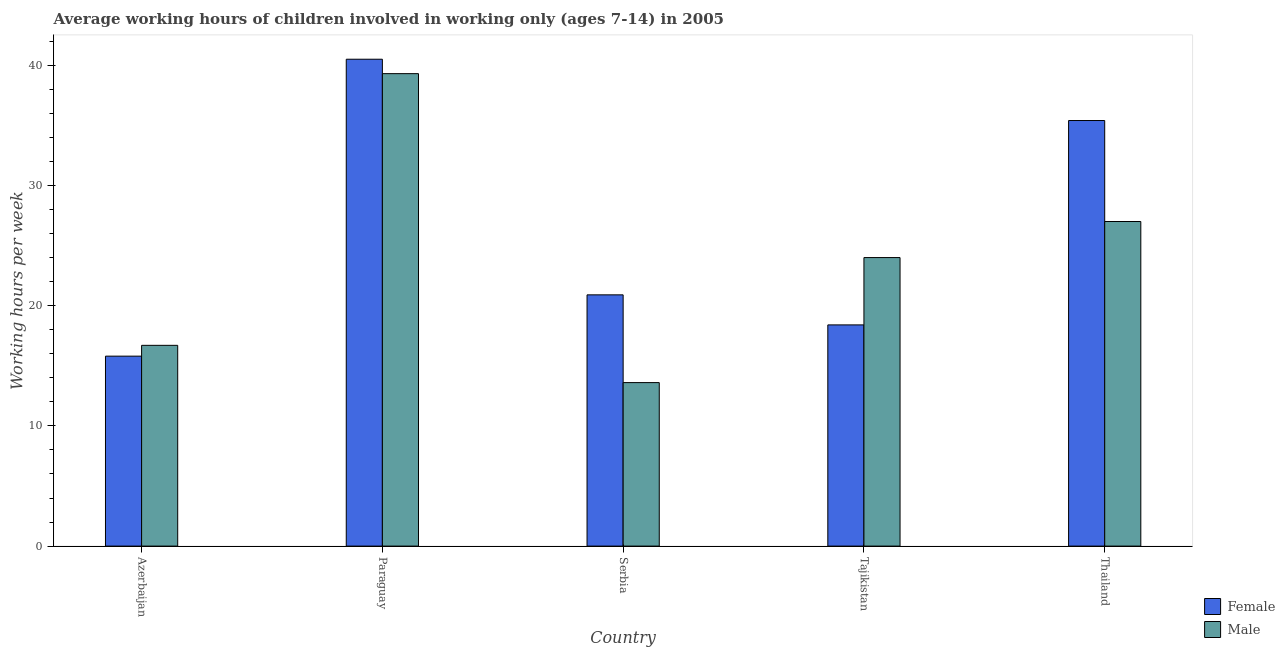How many different coloured bars are there?
Provide a succinct answer. 2. How many groups of bars are there?
Offer a terse response. 5. Are the number of bars per tick equal to the number of legend labels?
Ensure brevity in your answer.  Yes. How many bars are there on the 3rd tick from the left?
Make the answer very short. 2. What is the label of the 5th group of bars from the left?
Your response must be concise. Thailand. Across all countries, what is the maximum average working hour of female children?
Provide a succinct answer. 40.5. In which country was the average working hour of male children maximum?
Offer a very short reply. Paraguay. In which country was the average working hour of male children minimum?
Provide a short and direct response. Serbia. What is the total average working hour of male children in the graph?
Give a very brief answer. 120.6. What is the difference between the average working hour of male children in Paraguay and that in Thailand?
Your response must be concise. 12.3. What is the difference between the average working hour of male children in Tajikistan and the average working hour of female children in Serbia?
Give a very brief answer. 3.1. What is the average average working hour of female children per country?
Provide a succinct answer. 26.2. What is the difference between the average working hour of male children and average working hour of female children in Azerbaijan?
Make the answer very short. 0.9. In how many countries, is the average working hour of female children greater than 36 hours?
Keep it short and to the point. 1. What is the ratio of the average working hour of male children in Paraguay to that in Serbia?
Provide a succinct answer. 2.89. Is the difference between the average working hour of male children in Paraguay and Thailand greater than the difference between the average working hour of female children in Paraguay and Thailand?
Your answer should be compact. Yes. What is the difference between the highest and the second highest average working hour of female children?
Your answer should be compact. 5.1. What is the difference between the highest and the lowest average working hour of male children?
Give a very brief answer. 25.7. Is the sum of the average working hour of female children in Serbia and Tajikistan greater than the maximum average working hour of male children across all countries?
Make the answer very short. No. What does the 2nd bar from the left in Tajikistan represents?
Give a very brief answer. Male. What does the 2nd bar from the right in Azerbaijan represents?
Your answer should be very brief. Female. How many bars are there?
Provide a succinct answer. 10. How many countries are there in the graph?
Provide a short and direct response. 5. Does the graph contain any zero values?
Ensure brevity in your answer.  No. How many legend labels are there?
Provide a short and direct response. 2. How are the legend labels stacked?
Offer a terse response. Vertical. What is the title of the graph?
Your answer should be very brief. Average working hours of children involved in working only (ages 7-14) in 2005. What is the label or title of the X-axis?
Keep it short and to the point. Country. What is the label or title of the Y-axis?
Offer a terse response. Working hours per week. What is the Working hours per week of Male in Azerbaijan?
Your answer should be very brief. 16.7. What is the Working hours per week in Female in Paraguay?
Make the answer very short. 40.5. What is the Working hours per week of Male in Paraguay?
Provide a short and direct response. 39.3. What is the Working hours per week of Female in Serbia?
Keep it short and to the point. 20.9. What is the Working hours per week in Male in Serbia?
Keep it short and to the point. 13.6. What is the Working hours per week in Male in Tajikistan?
Keep it short and to the point. 24. What is the Working hours per week in Female in Thailand?
Offer a very short reply. 35.4. Across all countries, what is the maximum Working hours per week in Female?
Ensure brevity in your answer.  40.5. Across all countries, what is the maximum Working hours per week of Male?
Make the answer very short. 39.3. Across all countries, what is the minimum Working hours per week of Female?
Provide a short and direct response. 15.8. What is the total Working hours per week of Female in the graph?
Provide a short and direct response. 131. What is the total Working hours per week of Male in the graph?
Offer a terse response. 120.6. What is the difference between the Working hours per week of Female in Azerbaijan and that in Paraguay?
Your answer should be compact. -24.7. What is the difference between the Working hours per week in Male in Azerbaijan and that in Paraguay?
Your answer should be very brief. -22.6. What is the difference between the Working hours per week in Male in Azerbaijan and that in Serbia?
Provide a succinct answer. 3.1. What is the difference between the Working hours per week in Female in Azerbaijan and that in Tajikistan?
Provide a succinct answer. -2.6. What is the difference between the Working hours per week in Male in Azerbaijan and that in Tajikistan?
Offer a terse response. -7.3. What is the difference between the Working hours per week in Female in Azerbaijan and that in Thailand?
Your answer should be compact. -19.6. What is the difference between the Working hours per week in Female in Paraguay and that in Serbia?
Your response must be concise. 19.6. What is the difference between the Working hours per week of Male in Paraguay and that in Serbia?
Offer a terse response. 25.7. What is the difference between the Working hours per week in Female in Paraguay and that in Tajikistan?
Provide a short and direct response. 22.1. What is the difference between the Working hours per week in Female in Paraguay and that in Thailand?
Your answer should be very brief. 5.1. What is the difference between the Working hours per week of Male in Paraguay and that in Thailand?
Keep it short and to the point. 12.3. What is the difference between the Working hours per week in Female in Serbia and that in Thailand?
Make the answer very short. -14.5. What is the difference between the Working hours per week in Male in Serbia and that in Thailand?
Give a very brief answer. -13.4. What is the difference between the Working hours per week of Female in Tajikistan and that in Thailand?
Provide a short and direct response. -17. What is the difference between the Working hours per week in Female in Azerbaijan and the Working hours per week in Male in Paraguay?
Your answer should be compact. -23.5. What is the difference between the Working hours per week in Female in Azerbaijan and the Working hours per week in Male in Tajikistan?
Provide a succinct answer. -8.2. What is the difference between the Working hours per week in Female in Azerbaijan and the Working hours per week in Male in Thailand?
Your answer should be compact. -11.2. What is the difference between the Working hours per week of Female in Paraguay and the Working hours per week of Male in Serbia?
Offer a terse response. 26.9. What is the difference between the Working hours per week in Female in Paraguay and the Working hours per week in Male in Tajikistan?
Your answer should be very brief. 16.5. What is the difference between the Working hours per week of Female in Paraguay and the Working hours per week of Male in Thailand?
Give a very brief answer. 13.5. What is the difference between the Working hours per week of Female in Serbia and the Working hours per week of Male in Tajikistan?
Offer a very short reply. -3.1. What is the difference between the Working hours per week in Female in Tajikistan and the Working hours per week in Male in Thailand?
Ensure brevity in your answer.  -8.6. What is the average Working hours per week in Female per country?
Keep it short and to the point. 26.2. What is the average Working hours per week of Male per country?
Your answer should be very brief. 24.12. What is the difference between the Working hours per week in Female and Working hours per week in Male in Azerbaijan?
Keep it short and to the point. -0.9. What is the difference between the Working hours per week of Female and Working hours per week of Male in Tajikistan?
Give a very brief answer. -5.6. What is the difference between the Working hours per week in Female and Working hours per week in Male in Thailand?
Ensure brevity in your answer.  8.4. What is the ratio of the Working hours per week in Female in Azerbaijan to that in Paraguay?
Offer a very short reply. 0.39. What is the ratio of the Working hours per week in Male in Azerbaijan to that in Paraguay?
Your answer should be very brief. 0.42. What is the ratio of the Working hours per week of Female in Azerbaijan to that in Serbia?
Keep it short and to the point. 0.76. What is the ratio of the Working hours per week in Male in Azerbaijan to that in Serbia?
Your answer should be very brief. 1.23. What is the ratio of the Working hours per week in Female in Azerbaijan to that in Tajikistan?
Your answer should be very brief. 0.86. What is the ratio of the Working hours per week of Male in Azerbaijan to that in Tajikistan?
Keep it short and to the point. 0.7. What is the ratio of the Working hours per week in Female in Azerbaijan to that in Thailand?
Provide a succinct answer. 0.45. What is the ratio of the Working hours per week in Male in Azerbaijan to that in Thailand?
Provide a short and direct response. 0.62. What is the ratio of the Working hours per week in Female in Paraguay to that in Serbia?
Give a very brief answer. 1.94. What is the ratio of the Working hours per week of Male in Paraguay to that in Serbia?
Provide a short and direct response. 2.89. What is the ratio of the Working hours per week of Female in Paraguay to that in Tajikistan?
Keep it short and to the point. 2.2. What is the ratio of the Working hours per week in Male in Paraguay to that in Tajikistan?
Keep it short and to the point. 1.64. What is the ratio of the Working hours per week in Female in Paraguay to that in Thailand?
Make the answer very short. 1.14. What is the ratio of the Working hours per week in Male in Paraguay to that in Thailand?
Your answer should be compact. 1.46. What is the ratio of the Working hours per week in Female in Serbia to that in Tajikistan?
Your answer should be compact. 1.14. What is the ratio of the Working hours per week in Male in Serbia to that in Tajikistan?
Your answer should be very brief. 0.57. What is the ratio of the Working hours per week in Female in Serbia to that in Thailand?
Make the answer very short. 0.59. What is the ratio of the Working hours per week of Male in Serbia to that in Thailand?
Your answer should be compact. 0.5. What is the ratio of the Working hours per week in Female in Tajikistan to that in Thailand?
Provide a succinct answer. 0.52. What is the ratio of the Working hours per week in Male in Tajikistan to that in Thailand?
Keep it short and to the point. 0.89. What is the difference between the highest and the lowest Working hours per week of Female?
Ensure brevity in your answer.  24.7. What is the difference between the highest and the lowest Working hours per week in Male?
Provide a short and direct response. 25.7. 